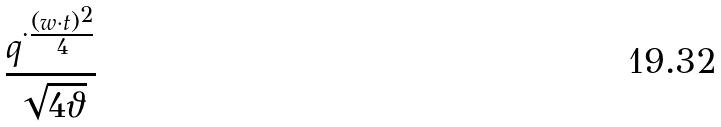Convert formula to latex. <formula><loc_0><loc_0><loc_500><loc_500>\frac { q ^ { \cdot \frac { ( w \cdot t ) ^ { 2 } } { 4 } } } { \sqrt { 4 \vartheta } }</formula> 